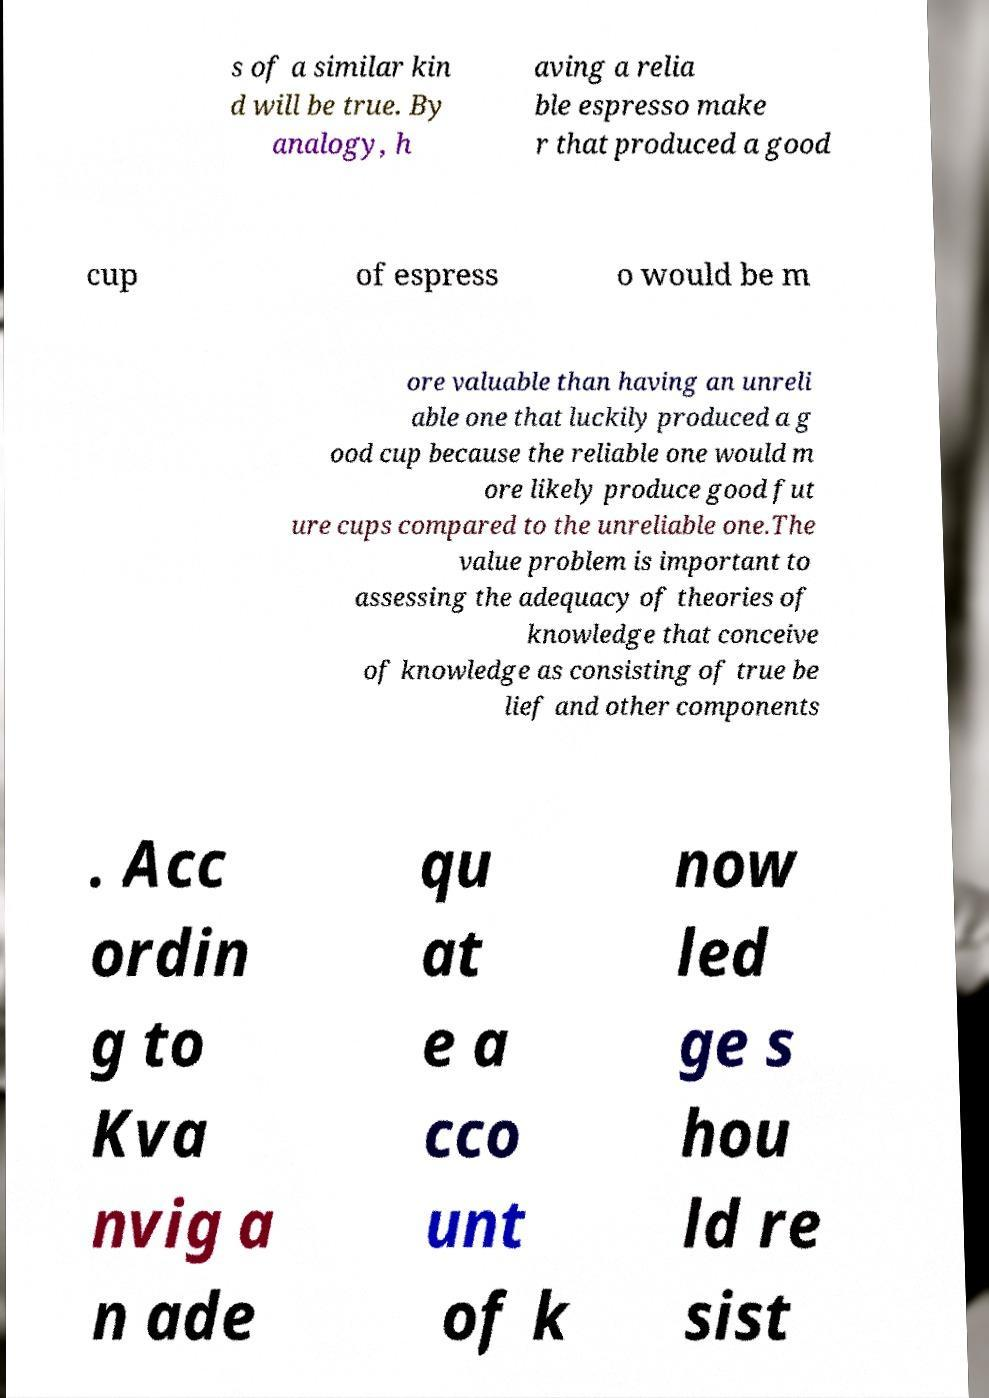Please read and relay the text visible in this image. What does it say? s of a similar kin d will be true. By analogy, h aving a relia ble espresso make r that produced a good cup of espress o would be m ore valuable than having an unreli able one that luckily produced a g ood cup because the reliable one would m ore likely produce good fut ure cups compared to the unreliable one.The value problem is important to assessing the adequacy of theories of knowledge that conceive of knowledge as consisting of true be lief and other components . Acc ordin g to Kva nvig a n ade qu at e a cco unt of k now led ge s hou ld re sist 